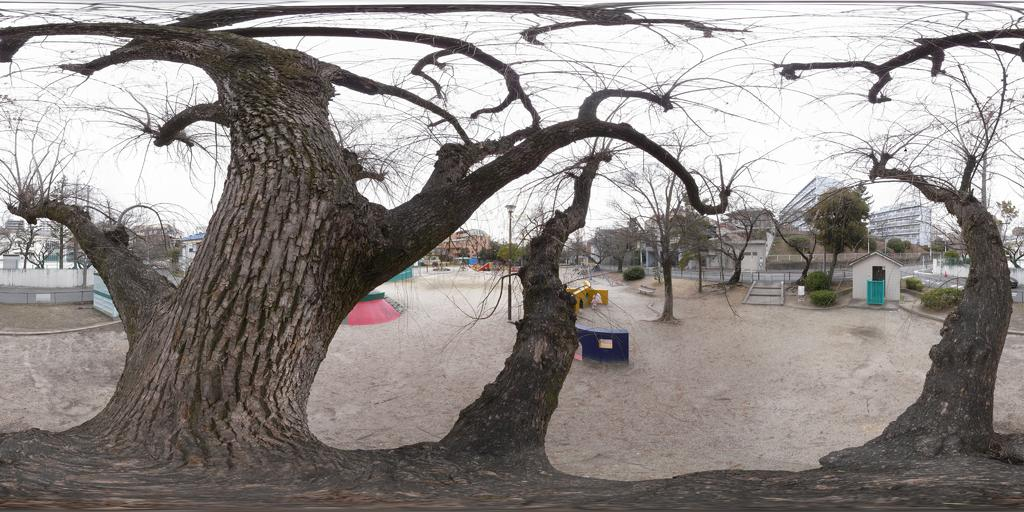What is the main object in the middle of the image? There is a tree in the middle of the image. What type of structure can be seen in the image? There is a tent house in the image. What other natural elements are present in the image? There are trees in the image. What man-made structures can be seen in the image? There are buildings in the image. What are the poles used for in the image? The purpose of the poles in the image is not specified, but they could be used for various purposes such as supporting structures or hanging objects. What other objects can be seen in the image? There are some objects in the image, but their specific nature is not mentioned in the facts provided. What is visible in the background of the image? The sky is visible in the image. Where is the crate of jewels hidden in the image? There is no crate of jewels present in the image. 